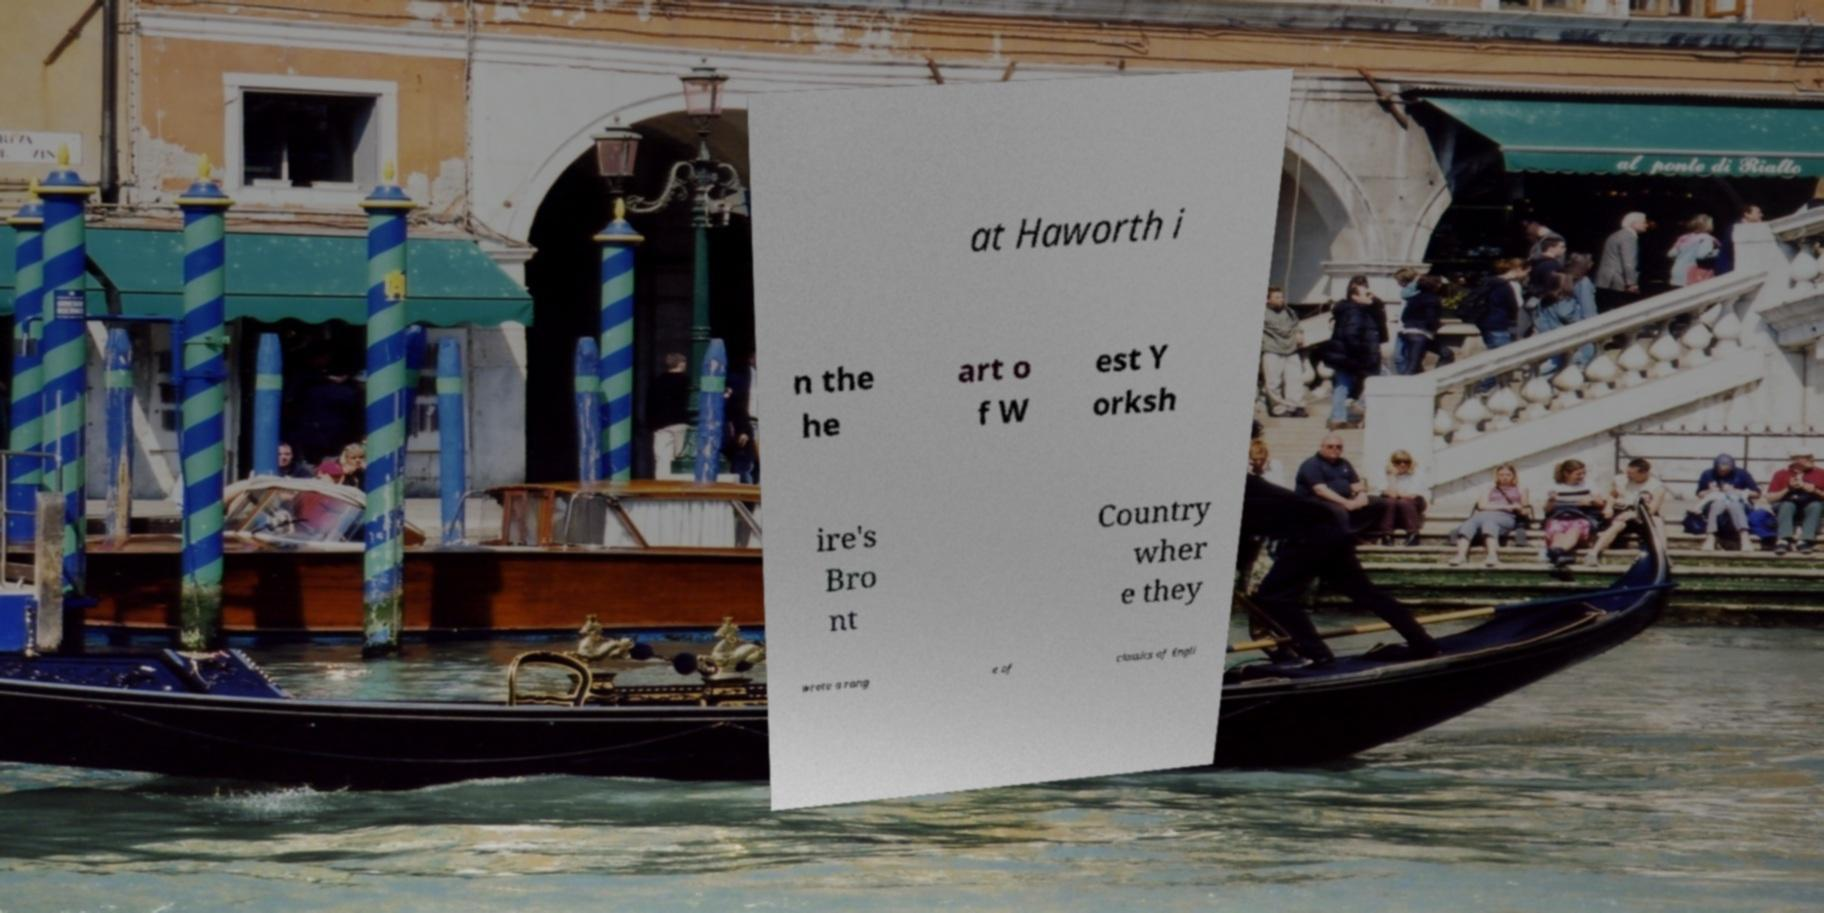What messages or text are displayed in this image? I need them in a readable, typed format. at Haworth i n the he art o f W est Y orksh ire's Bro nt Country wher e they wrote a rang e of classics of Engli 